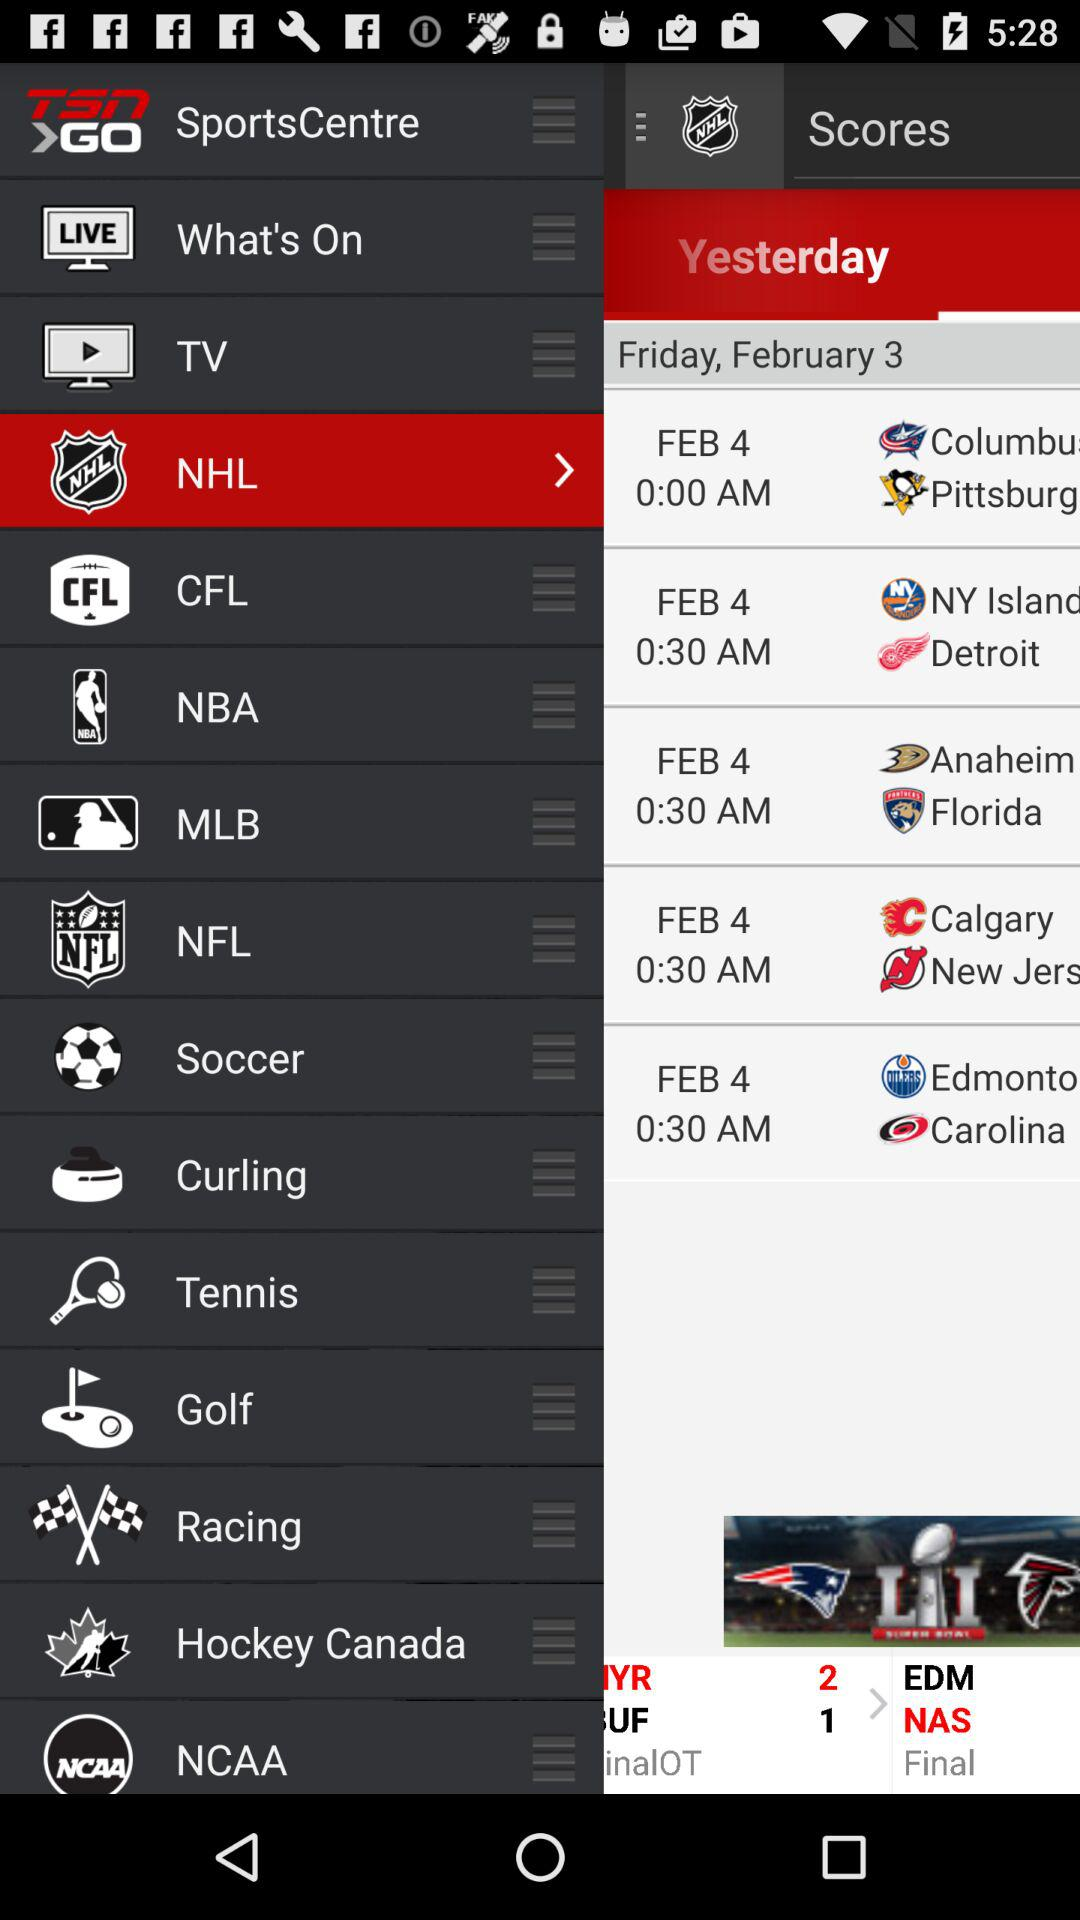What is the application name? The application name is "TSN GO SportsCentre". 